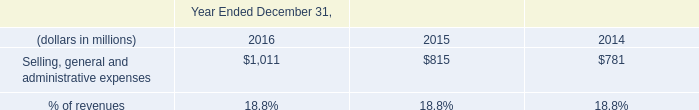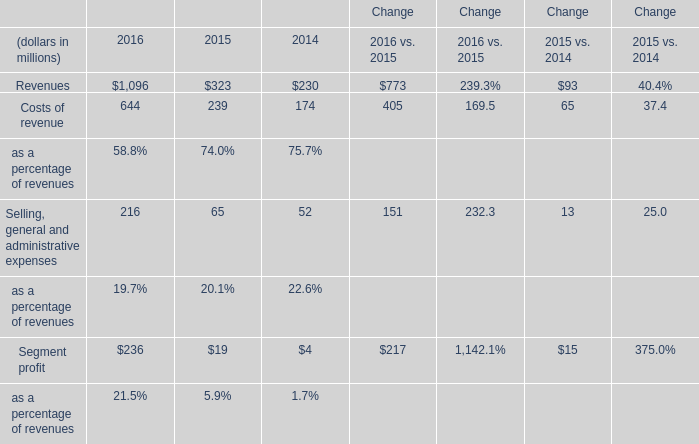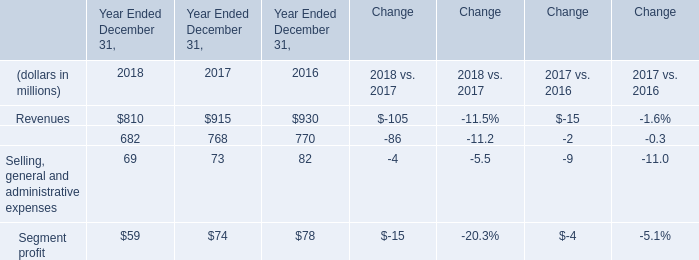Which year is Selling, general and administrative expenses the most? 
Answer: 2016. 